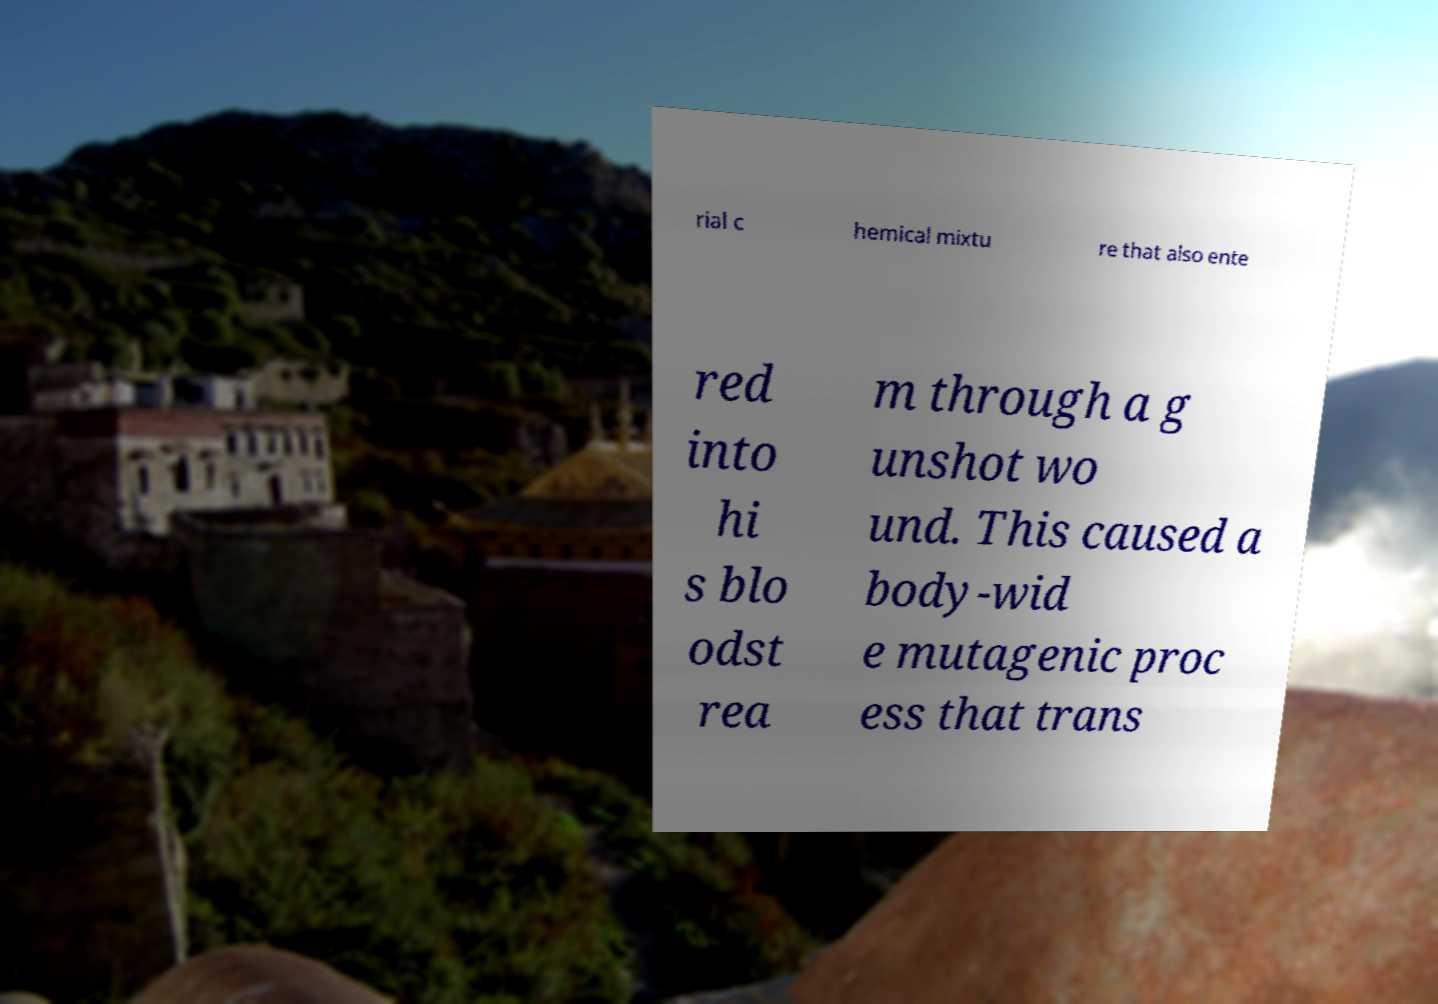What messages or text are displayed in this image? I need them in a readable, typed format. rial c hemical mixtu re that also ente red into hi s blo odst rea m through a g unshot wo und. This caused a body-wid e mutagenic proc ess that trans 